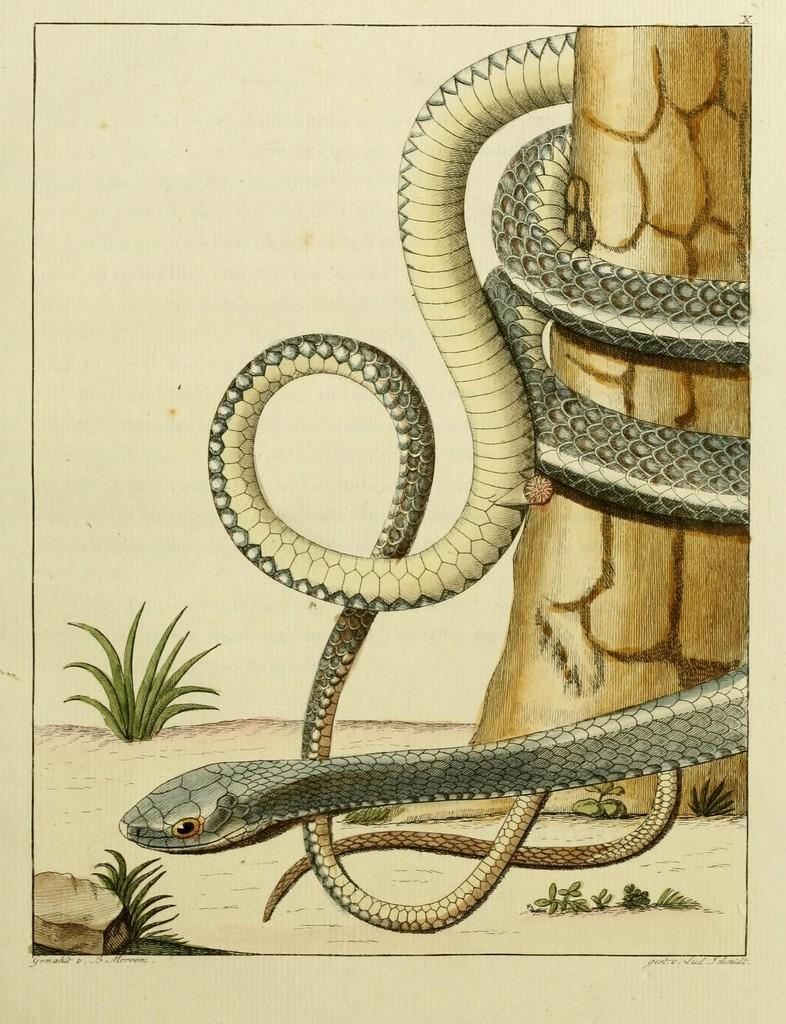What is the main subject of the image? The main subject of the image is a picture of a snake. Where is the snake located in the image? The snake is around a tree trunk in the image. What type of vegetation can be seen in the image? There is grass visible in the image. What other object can be seen in the image? There is a rock in the image. What type of polish is being used on the snake in the image? There is no polish present in the image. The image features a picture of a snake around a tree trunk, grass, and a rock. 